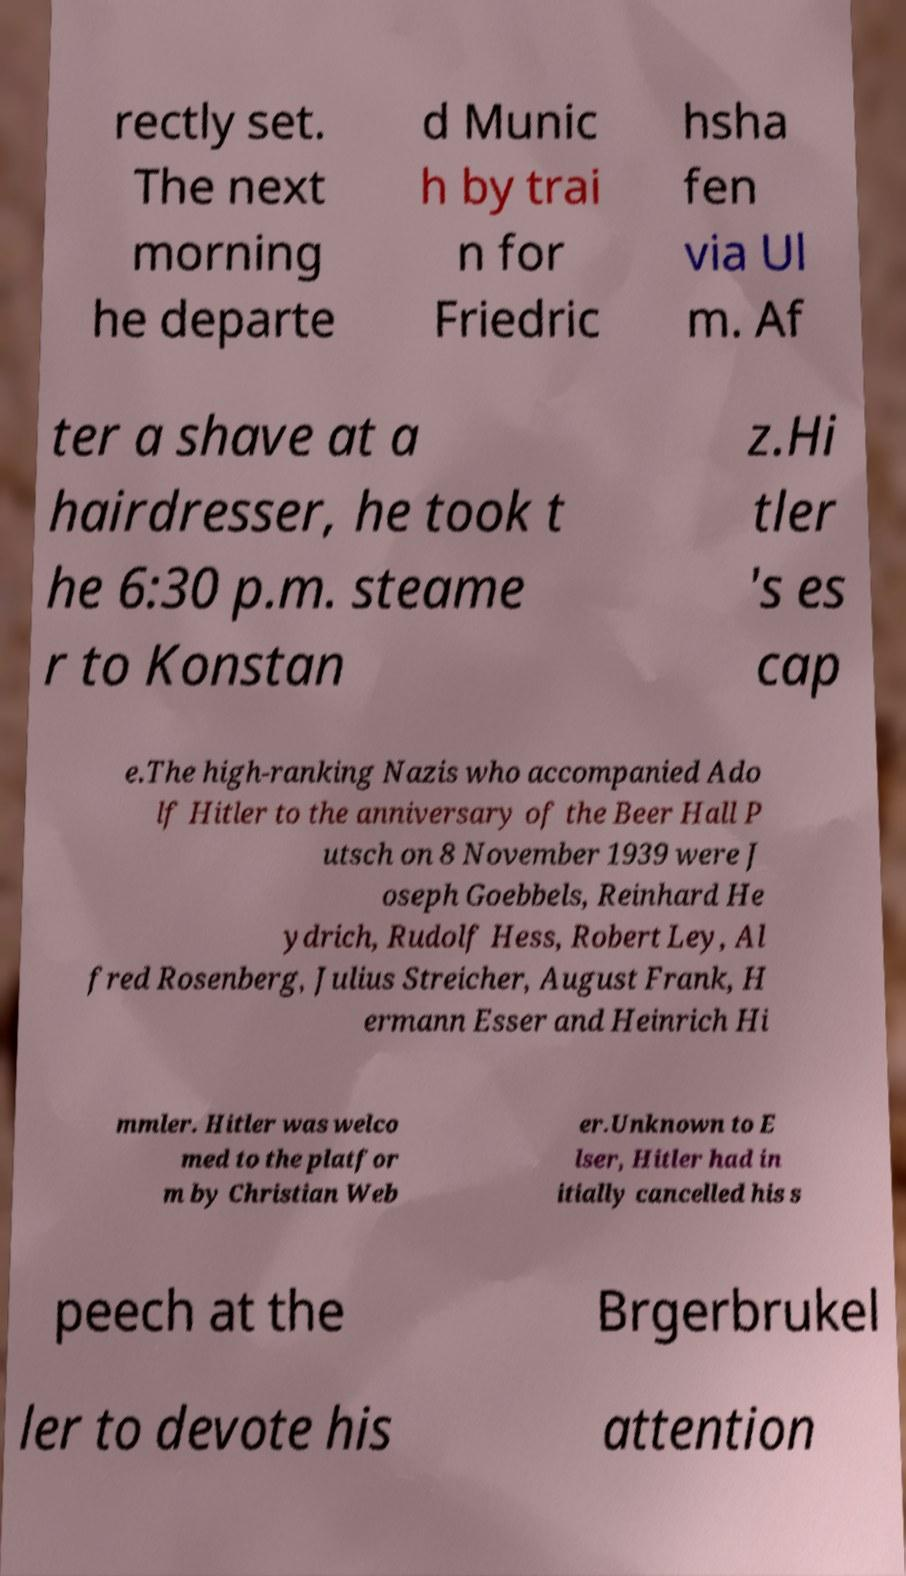What messages or text are displayed in this image? I need them in a readable, typed format. rectly set. The next morning he departe d Munic h by trai n for Friedric hsha fen via Ul m. Af ter a shave at a hairdresser, he took t he 6:30 p.m. steame r to Konstan z.Hi tler 's es cap e.The high-ranking Nazis who accompanied Ado lf Hitler to the anniversary of the Beer Hall P utsch on 8 November 1939 were J oseph Goebbels, Reinhard He ydrich, Rudolf Hess, Robert Ley, Al fred Rosenberg, Julius Streicher, August Frank, H ermann Esser and Heinrich Hi mmler. Hitler was welco med to the platfor m by Christian Web er.Unknown to E lser, Hitler had in itially cancelled his s peech at the Brgerbrukel ler to devote his attention 